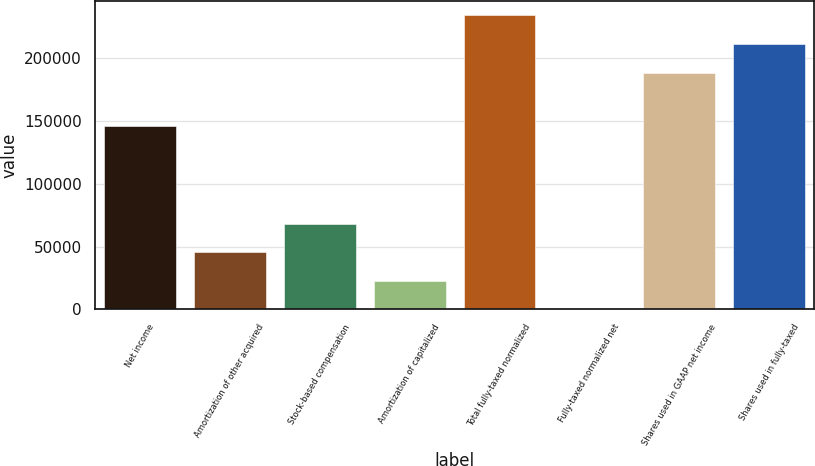Convert chart. <chart><loc_0><loc_0><loc_500><loc_500><bar_chart><fcel>Net income<fcel>Amortization of other acquired<fcel>Stock-based compensation<fcel>Amortization of capitalized<fcel>Total fully-taxed normalized<fcel>Fully-taxed normalized net<fcel>Shares used in GAAP net income<fcel>Shares used in fully-taxed<nl><fcel>145913<fcel>45569.4<fcel>68353.5<fcel>22785.3<fcel>234226<fcel>1.22<fcel>188658<fcel>211442<nl></chart> 